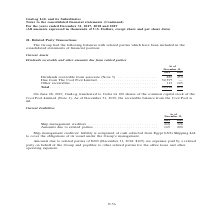According to Gaslog's financial document, How many shares of Cool Pool Limited was transferred to Golar? According to the financial document, 100. The relevant text states: "On June 28, 2019, GasLog transferred to Golar its 100 shares of the common capital stock of the Cool Pool Limited (Note 1). As of December 31, 2019, the..." Also, What is the amount due from The Cool Pool Limited in 2018? According to the financial document, 32,397 (in thousands). The relevant text states: "ote 5) . 885 450 Due from The Cool Pool Limited . 32,397 — Other receivables . 113 123 Total . 33,395 573..." Also, In which years was the dividends receivable and other amounts due from related parties recorded for? The document shows two values: 2018 and 2019. From the document: ") For the years ended December 31, 2017, 2018 and 2019 (All amounts expressed in thousands of U.S. Dollars, except share and per share data) Continued..." Additionally, Which year was the dividends receivable from associate higher? According to the financial document, 2018. The relevant text states: "Continued) For the years ended December 31, 2017, 2018 and 2019 (All amounts expressed in thousands of U.S. Dollars, except share and per share data)..." Also, can you calculate: What was the change in other receivables from 2018 to 2019? Based on the calculation: 123 - 113 , the result is 10 (in thousands). This is based on the information: "Cool Pool Limited . 32,397 — Other receivables . 113 123 Total . 33,395 573 l Pool Limited . 32,397 — Other receivables . 113 123 Total . 33,395 573..." The key data points involved are: 113, 123. Also, can you calculate: What was the percentage change in total from 2018 to 2019? To answer this question, I need to perform calculations using the financial data. The calculation is: (573 - 33,395)/33,395 , which equals -98.28 (percentage). This is based on the information: "ed . 32,397 — Other receivables . 113 123 Total . 33,395 573 ,397 — Other receivables . 113 123 Total . 33,395 573..." The key data points involved are: 33,395, 573. 